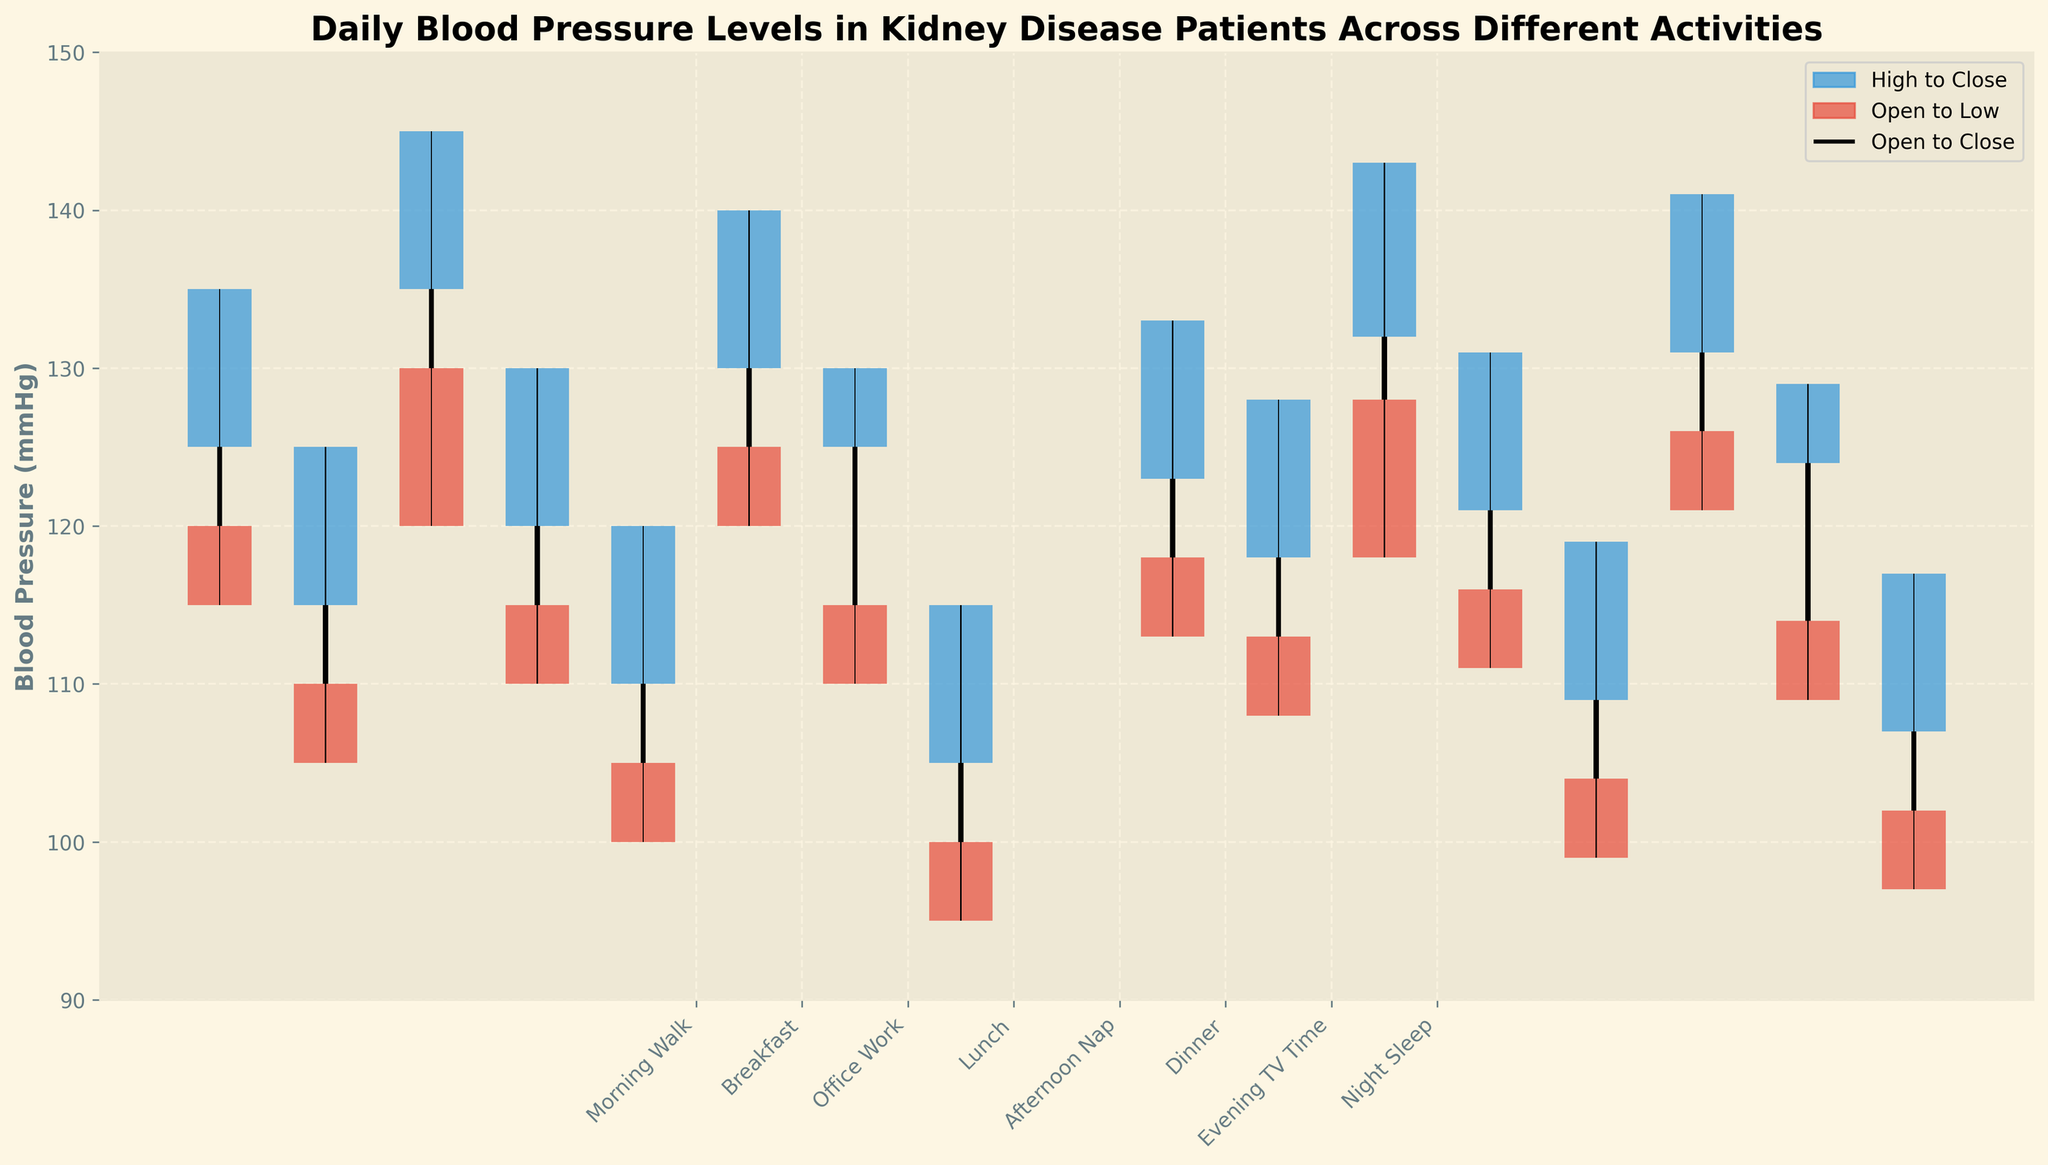what is the highest blood pressure level recorded during morning walks? The highest blood pressure level recorded during morning walks is represented by the highest point of the upward blue bar for the "Morning Walk" activity. The highest value is 135 mmHg on 2023-10-01.
Answer: 135 mmHg what is the lowest blood pressure level during office work on 2023-10-02? The lowest blood pressure level during office work on 2023-10-02 is represented by the lowest point on the downward red bar for the "Office Work" activity on that day. The lowest value is 118 mmHg.
Answer: 118 mmHg what activity shows the smallest difference between the highest and lowest blood pressure levels? To find the activity with the smallest difference, you compare the height of each candlestick (the distance from the top of the blue bar to the bottom of the red bar). The shortest candlestick, representing the smallest range, is found for the "Afternoon Nap" activity.
Answer: Afternoon Nap which activity experienced the largest increase in blood pressure during 2023-10-02, from the beginning to the end? The activity with the largest increase in blood pressure from open to close can be inferred from the height of the narrow black bar, showing an upward trend. Dinner on 2023-10-02 has the largest increase from the open (126 mmHg) to the close (131 mmHg).
Answer: Dinner how does the blood pressure range during breakfast compare between the two days? The blood pressure range is determined by the difference between the high and low values. For breakfast on 2023-10-01, the range is 125 - 105 = 20 mmHg. For breakfast on 2023-10-02, the range is 128 - 108 = 20 mmHg. Both ranges are equal.
Answer: Equal what is the average closing blood pressure level during evening TV time across the two days? To find the average, add the closing values for evening TV time on 2023-10-01 (125 mmHg) and 2023-10-02 (124 mmHg) and divide by 2. (125 + 124) / 2 = 124.5 mmHg.
Answer: 124.5 mmHg which period records the lowest closing blood pressure level? The lowest closing blood pressure level can be identified by finding the lowest endpoint of the black narrow bars across all activities and dates. The lowest closing value is during night sleep on both days: 105 mmHg on 2023-10-01.
Answer: Night Sleep which activity had the highest volatility in blood pressure levels on both days combined? Volatility is represented by the height of the candlestick bars (the range between the high and low values). The activity with the highest total height of combined candlesticks across both days is "Office Work", indicating the highest volatility.
Answer: Office Work 